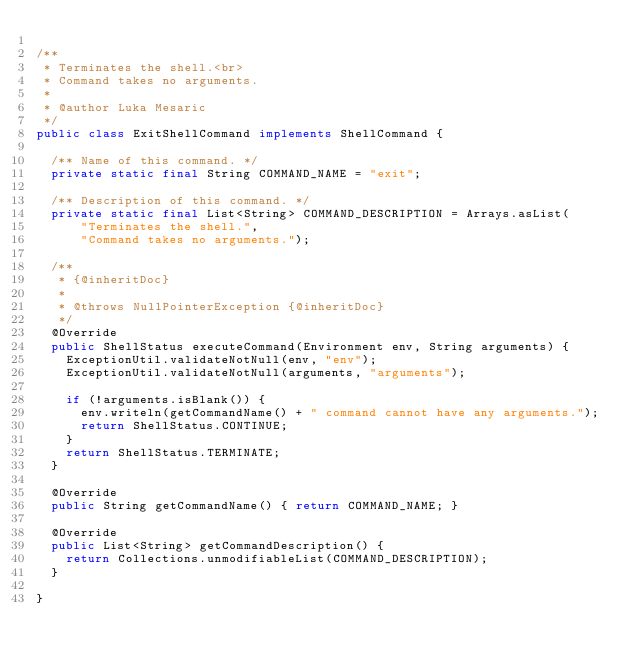Convert code to text. <code><loc_0><loc_0><loc_500><loc_500><_Java_>
/**
 * Terminates the shell.<br>
 * Command takes no arguments.
 * 
 * @author Luka Mesaric
 */
public class ExitShellCommand implements ShellCommand {

	/** Name of this command. */
	private static final String COMMAND_NAME = "exit";

	/** Description of this command. */
	private static final List<String> COMMAND_DESCRIPTION = Arrays.asList(
			"Terminates the shell.",
			"Command takes no arguments.");

	/**
	 * {@inheritDoc}
	 * 
	 * @throws NullPointerException {@inheritDoc}
	 */
	@Override
	public ShellStatus executeCommand(Environment env, String arguments) {
		ExceptionUtil.validateNotNull(env, "env");
		ExceptionUtil.validateNotNull(arguments, "arguments");

		if (!arguments.isBlank()) {
			env.writeln(getCommandName() + " command cannot have any arguments.");
			return ShellStatus.CONTINUE;
		}
		return ShellStatus.TERMINATE;
	}

	@Override
	public String getCommandName() { return COMMAND_NAME; }

	@Override
	public List<String> getCommandDescription() {
		return Collections.unmodifiableList(COMMAND_DESCRIPTION);
	}

}
</code> 